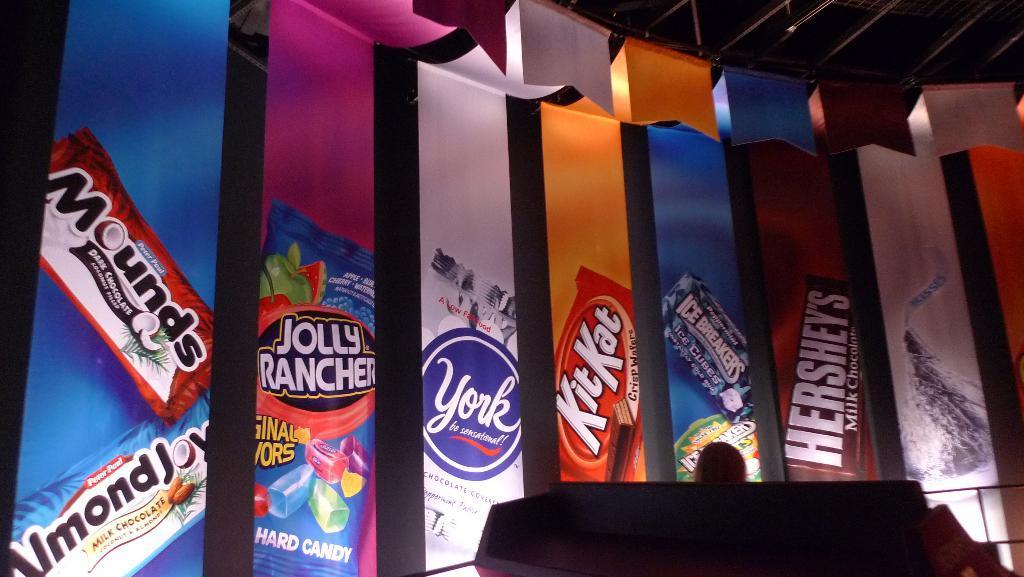How would you summarize this image in a sentence or two? In this image, we can see few banners. Top of the image, there are few rods and ropes. At the bottom, we can see some black color object. Here can see a human head. 